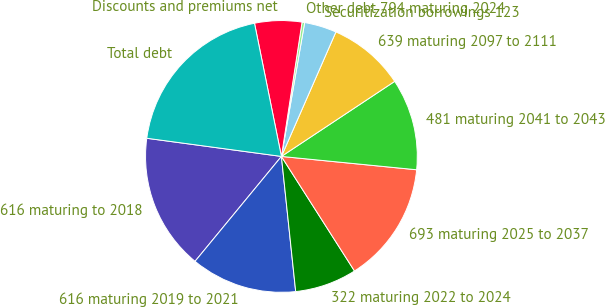<chart> <loc_0><loc_0><loc_500><loc_500><pie_chart><fcel>616 maturing to 2018<fcel>616 maturing 2019 to 2021<fcel>322 maturing 2022 to 2024<fcel>693 maturing 2025 to 2037<fcel>481 maturing 2041 to 2043<fcel>639 maturing 2097 to 2111<fcel>Securitization borrowings 123<fcel>Other debt 794 maturing 2024<fcel>Discounts and premiums net<fcel>Total debt<nl><fcel>16.17%<fcel>12.64%<fcel>7.36%<fcel>14.4%<fcel>10.88%<fcel>9.12%<fcel>3.83%<fcel>0.31%<fcel>5.6%<fcel>19.69%<nl></chart> 